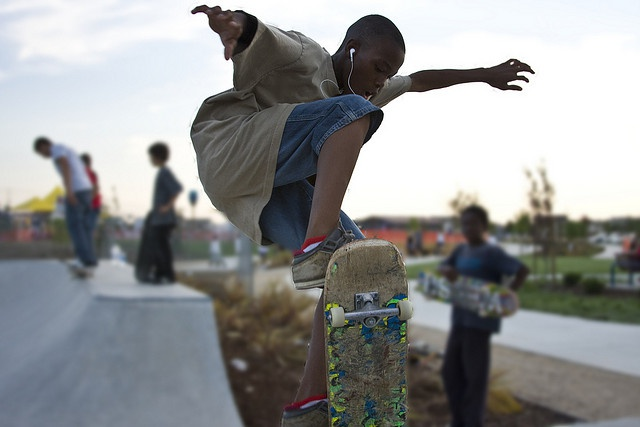Describe the objects in this image and their specific colors. I can see people in lavender, black, and gray tones, skateboard in lavender, gray, black, darkgreen, and darkgray tones, people in lavender, black, gray, and darkgreen tones, people in lavender, gray, navy, black, and darkgray tones, and people in lavender, black, and gray tones in this image. 